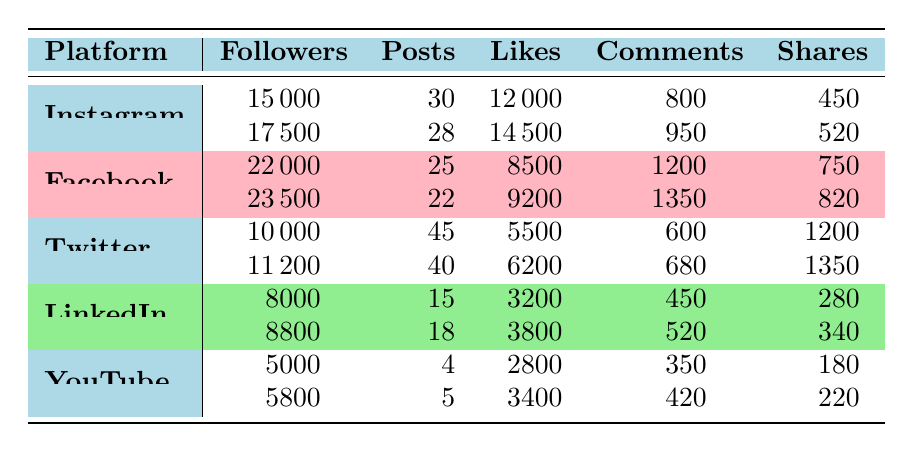What was the number of followers on Instagram in February? Referring to the table, the number of followers on Instagram for February is listed as 17500.
Answer: 17500 How many total likes did Facebook receive in January and February? The number of likes in January is 8500, and in February it is 9200. Adding them together: 8500 + 9200 = 17700.
Answer: 17700 Which platform had the highest number of shares in January? Looking at the shares in January, Facebook had 750 shares, Instagram had 450, Twitter had 1200, LinkedIn had 280, and YouTube had 180. The highest is Twitter with 1200 shares.
Answer: Twitter Is the number of posts on YouTube greater in February than in January? YouTube had 4 posts in January and 5 posts in February. Since 5 is greater than 4, the answer is yes.
Answer: Yes What is the average number of followers across all platforms in February? In February, the followers are: Instagram 17500, Facebook 23500, Twitter 11200, LinkedIn 8800, and YouTube 5800. Adding these: 17500 + 23500 + 11200 + 8800 + 5800 = 73800. There are 5 platforms, so averaging: 73800 / 5 = 14760.
Answer: 14760 Which platform experienced the largest increase in followers from January to February? For each platform: Instagram increased from 15000 to 17500 (+2500), Facebook from 22000 to 23500 (+1500), Twitter from 10000 to 11200 (+1200), LinkedIn from 8000 to 8800 (+800), and YouTube from 5000 to 5800 (+800). The largest increase is Instagram with +2500.
Answer: Instagram How many likes did LinkedIn receive in total across January and February? In January, LinkedIn received 3200 likes, and in February it received 3800 likes. Adding these gives: 3200 + 3800 = 7000 likes in total.
Answer: 7000 Was the number of comments on Twitter higher than on LinkedIn in January? Twitter had 600 comments and LinkedIn had 450 comments in January. Since 600 is greater than 450, the answer is yes.
Answer: Yes What is the difference in the number of posts between Instagram and YouTube in February? In February, Instagram had 28 posts and YouTube had 5 posts. The difference is calculated as: 28 - 5 = 23.
Answer: 23 